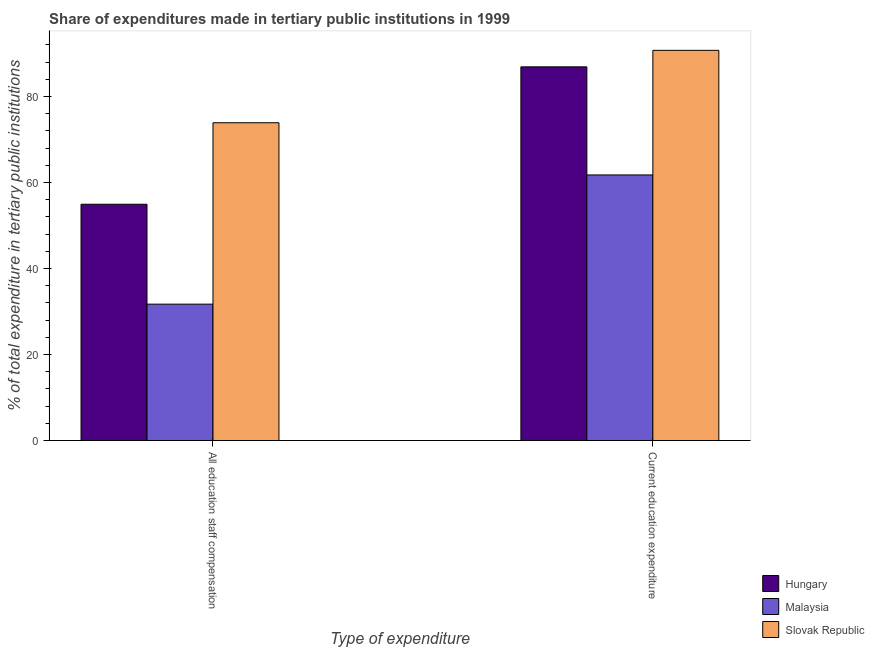How many different coloured bars are there?
Keep it short and to the point. 3. How many groups of bars are there?
Provide a succinct answer. 2. How many bars are there on the 1st tick from the left?
Make the answer very short. 3. What is the label of the 1st group of bars from the left?
Offer a terse response. All education staff compensation. What is the expenditure in staff compensation in Malaysia?
Provide a succinct answer. 31.71. Across all countries, what is the maximum expenditure in staff compensation?
Give a very brief answer. 73.88. Across all countries, what is the minimum expenditure in staff compensation?
Offer a terse response. 31.71. In which country was the expenditure in education maximum?
Provide a short and direct response. Slovak Republic. In which country was the expenditure in education minimum?
Give a very brief answer. Malaysia. What is the total expenditure in education in the graph?
Your answer should be compact. 239.33. What is the difference between the expenditure in staff compensation in Slovak Republic and that in Malaysia?
Offer a very short reply. 42.17. What is the difference between the expenditure in staff compensation in Slovak Republic and the expenditure in education in Hungary?
Provide a succinct answer. -12.99. What is the average expenditure in education per country?
Provide a short and direct response. 79.78. What is the difference between the expenditure in education and expenditure in staff compensation in Malaysia?
Your answer should be compact. 30.04. In how many countries, is the expenditure in staff compensation greater than 16 %?
Offer a very short reply. 3. What is the ratio of the expenditure in education in Malaysia to that in Hungary?
Your answer should be compact. 0.71. What does the 2nd bar from the left in All education staff compensation represents?
Your answer should be very brief. Malaysia. What does the 1st bar from the right in All education staff compensation represents?
Your answer should be very brief. Slovak Republic. Are all the bars in the graph horizontal?
Offer a terse response. No. How many countries are there in the graph?
Keep it short and to the point. 3. How many legend labels are there?
Make the answer very short. 3. How are the legend labels stacked?
Give a very brief answer. Vertical. What is the title of the graph?
Offer a very short reply. Share of expenditures made in tertiary public institutions in 1999. What is the label or title of the X-axis?
Provide a succinct answer. Type of expenditure. What is the label or title of the Y-axis?
Provide a succinct answer. % of total expenditure in tertiary public institutions. What is the % of total expenditure in tertiary public institutions of Hungary in All education staff compensation?
Your response must be concise. 54.94. What is the % of total expenditure in tertiary public institutions in Malaysia in All education staff compensation?
Your answer should be very brief. 31.71. What is the % of total expenditure in tertiary public institutions in Slovak Republic in All education staff compensation?
Give a very brief answer. 73.88. What is the % of total expenditure in tertiary public institutions of Hungary in Current education expenditure?
Provide a short and direct response. 86.87. What is the % of total expenditure in tertiary public institutions in Malaysia in Current education expenditure?
Your answer should be very brief. 61.75. What is the % of total expenditure in tertiary public institutions of Slovak Republic in Current education expenditure?
Provide a short and direct response. 90.71. Across all Type of expenditure, what is the maximum % of total expenditure in tertiary public institutions of Hungary?
Offer a terse response. 86.87. Across all Type of expenditure, what is the maximum % of total expenditure in tertiary public institutions of Malaysia?
Keep it short and to the point. 61.75. Across all Type of expenditure, what is the maximum % of total expenditure in tertiary public institutions in Slovak Republic?
Your answer should be very brief. 90.71. Across all Type of expenditure, what is the minimum % of total expenditure in tertiary public institutions in Hungary?
Your answer should be compact. 54.94. Across all Type of expenditure, what is the minimum % of total expenditure in tertiary public institutions in Malaysia?
Make the answer very short. 31.71. Across all Type of expenditure, what is the minimum % of total expenditure in tertiary public institutions in Slovak Republic?
Your response must be concise. 73.88. What is the total % of total expenditure in tertiary public institutions of Hungary in the graph?
Your answer should be compact. 141.81. What is the total % of total expenditure in tertiary public institutions of Malaysia in the graph?
Make the answer very short. 93.46. What is the total % of total expenditure in tertiary public institutions in Slovak Republic in the graph?
Your answer should be compact. 164.59. What is the difference between the % of total expenditure in tertiary public institutions in Hungary in All education staff compensation and that in Current education expenditure?
Keep it short and to the point. -31.94. What is the difference between the % of total expenditure in tertiary public institutions in Malaysia in All education staff compensation and that in Current education expenditure?
Provide a succinct answer. -30.04. What is the difference between the % of total expenditure in tertiary public institutions of Slovak Republic in All education staff compensation and that in Current education expenditure?
Ensure brevity in your answer.  -16.83. What is the difference between the % of total expenditure in tertiary public institutions of Hungary in All education staff compensation and the % of total expenditure in tertiary public institutions of Malaysia in Current education expenditure?
Keep it short and to the point. -6.81. What is the difference between the % of total expenditure in tertiary public institutions of Hungary in All education staff compensation and the % of total expenditure in tertiary public institutions of Slovak Republic in Current education expenditure?
Provide a succinct answer. -35.78. What is the difference between the % of total expenditure in tertiary public institutions of Malaysia in All education staff compensation and the % of total expenditure in tertiary public institutions of Slovak Republic in Current education expenditure?
Make the answer very short. -59. What is the average % of total expenditure in tertiary public institutions in Hungary per Type of expenditure?
Provide a short and direct response. 70.9. What is the average % of total expenditure in tertiary public institutions of Malaysia per Type of expenditure?
Offer a very short reply. 46.73. What is the average % of total expenditure in tertiary public institutions of Slovak Republic per Type of expenditure?
Offer a terse response. 82.3. What is the difference between the % of total expenditure in tertiary public institutions of Hungary and % of total expenditure in tertiary public institutions of Malaysia in All education staff compensation?
Your answer should be very brief. 23.22. What is the difference between the % of total expenditure in tertiary public institutions in Hungary and % of total expenditure in tertiary public institutions in Slovak Republic in All education staff compensation?
Provide a succinct answer. -18.94. What is the difference between the % of total expenditure in tertiary public institutions in Malaysia and % of total expenditure in tertiary public institutions in Slovak Republic in All education staff compensation?
Your response must be concise. -42.17. What is the difference between the % of total expenditure in tertiary public institutions in Hungary and % of total expenditure in tertiary public institutions in Malaysia in Current education expenditure?
Your response must be concise. 25.12. What is the difference between the % of total expenditure in tertiary public institutions of Hungary and % of total expenditure in tertiary public institutions of Slovak Republic in Current education expenditure?
Keep it short and to the point. -3.84. What is the difference between the % of total expenditure in tertiary public institutions of Malaysia and % of total expenditure in tertiary public institutions of Slovak Republic in Current education expenditure?
Give a very brief answer. -28.96. What is the ratio of the % of total expenditure in tertiary public institutions of Hungary in All education staff compensation to that in Current education expenditure?
Offer a very short reply. 0.63. What is the ratio of the % of total expenditure in tertiary public institutions in Malaysia in All education staff compensation to that in Current education expenditure?
Offer a very short reply. 0.51. What is the ratio of the % of total expenditure in tertiary public institutions of Slovak Republic in All education staff compensation to that in Current education expenditure?
Your answer should be very brief. 0.81. What is the difference between the highest and the second highest % of total expenditure in tertiary public institutions in Hungary?
Your answer should be very brief. 31.94. What is the difference between the highest and the second highest % of total expenditure in tertiary public institutions in Malaysia?
Keep it short and to the point. 30.04. What is the difference between the highest and the second highest % of total expenditure in tertiary public institutions of Slovak Republic?
Your response must be concise. 16.83. What is the difference between the highest and the lowest % of total expenditure in tertiary public institutions of Hungary?
Make the answer very short. 31.94. What is the difference between the highest and the lowest % of total expenditure in tertiary public institutions in Malaysia?
Your answer should be compact. 30.04. What is the difference between the highest and the lowest % of total expenditure in tertiary public institutions of Slovak Republic?
Make the answer very short. 16.83. 